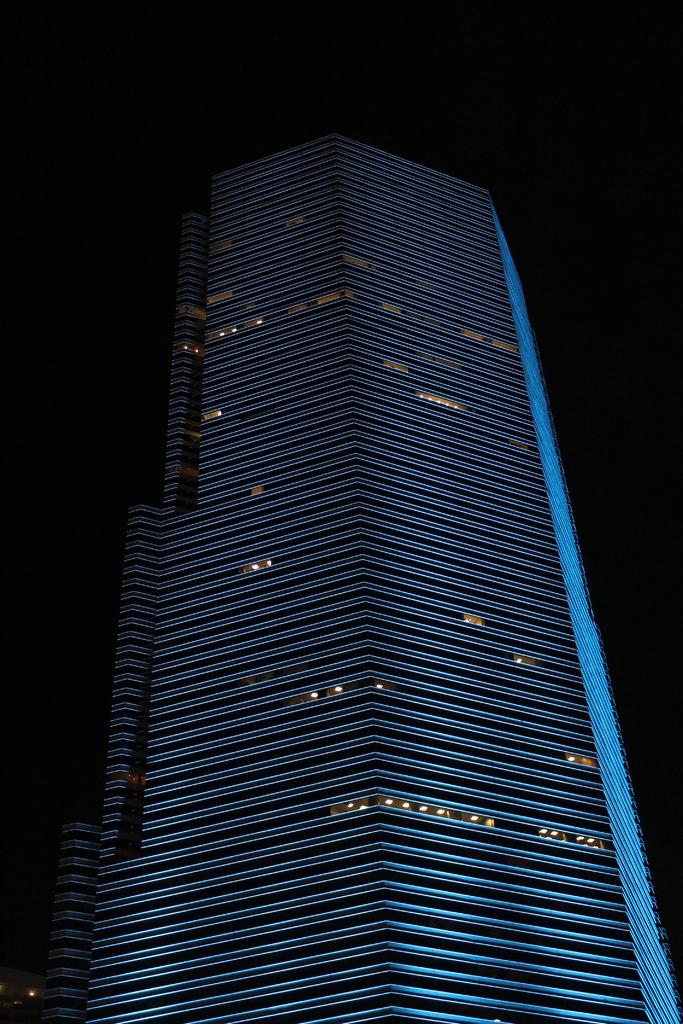What type of structure is visible in the image? There is a building in the image. How many celery stalks can be seen on the chairs in the image? There are no chairs or celery stalks present in the image; it only features a building. 